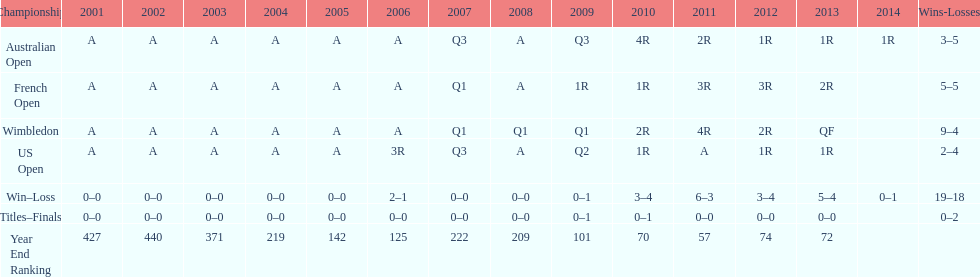How many tournaments had 5 total losses? 2. Can you give me this table as a dict? {'header': ['Championship', '2001', '2002', '2003', '2004', '2005', '2006', '2007', '2008', '2009', '2010', '2011', '2012', '2013', '2014', 'Wins-Losses'], 'rows': [['Australian Open', 'A', 'A', 'A', 'A', 'A', 'A', 'Q3', 'A', 'Q3', '4R', '2R', '1R', '1R', '1R', '3–5'], ['French Open', 'A', 'A', 'A', 'A', 'A', 'A', 'Q1', 'A', '1R', '1R', '3R', '3R', '2R', '', '5–5'], ['Wimbledon', 'A', 'A', 'A', 'A', 'A', 'A', 'Q1', 'Q1', 'Q1', '2R', '4R', '2R', 'QF', '', '9–4'], ['US Open', 'A', 'A', 'A', 'A', 'A', '3R', 'Q3', 'A', 'Q2', '1R', 'A', '1R', '1R', '', '2–4'], ['Win–Loss', '0–0', '0–0', '0–0', '0–0', '0–0', '2–1', '0–0', '0–0', '0–1', '3–4', '6–3', '3–4', '5–4', '0–1', '19–18'], ['Titles–Finals', '0–0', '0–0', '0–0', '0–0', '0–0', '0–0', '0–0', '0–0', '0–1', '0–1', '0–0', '0–0', '0–0', '', '0–2'], ['Year End Ranking', '427', '440', '371', '219', '142', '125', '222', '209', '101', '70', '57', '74', '72', '', '']]} 